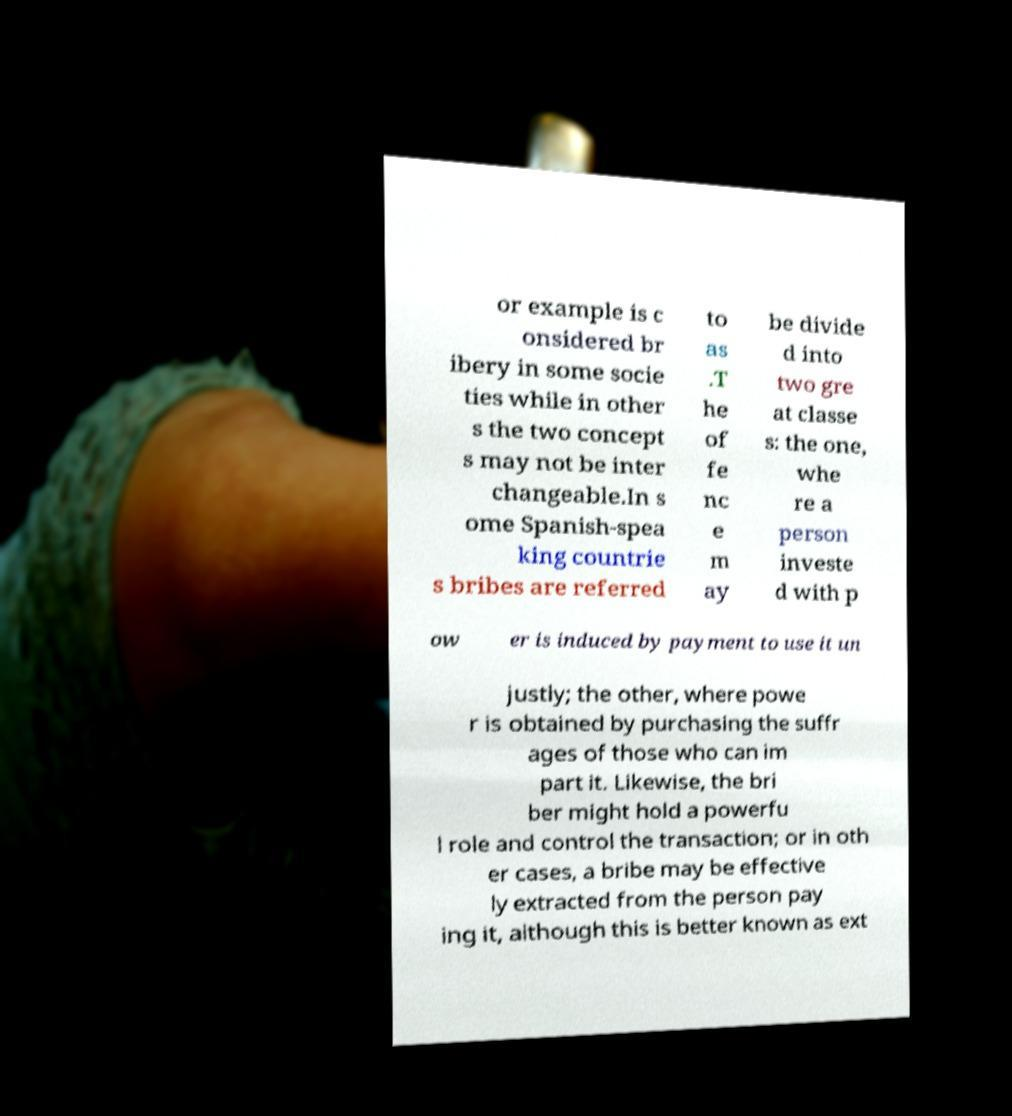Could you extract and type out the text from this image? or example is c onsidered br ibery in some socie ties while in other s the two concept s may not be inter changeable.In s ome Spanish-spea king countrie s bribes are referred to as .T he of fe nc e m ay be divide d into two gre at classe s: the one, whe re a person investe d with p ow er is induced by payment to use it un justly; the other, where powe r is obtained by purchasing the suffr ages of those who can im part it. Likewise, the bri ber might hold a powerfu l role and control the transaction; or in oth er cases, a bribe may be effective ly extracted from the person pay ing it, although this is better known as ext 